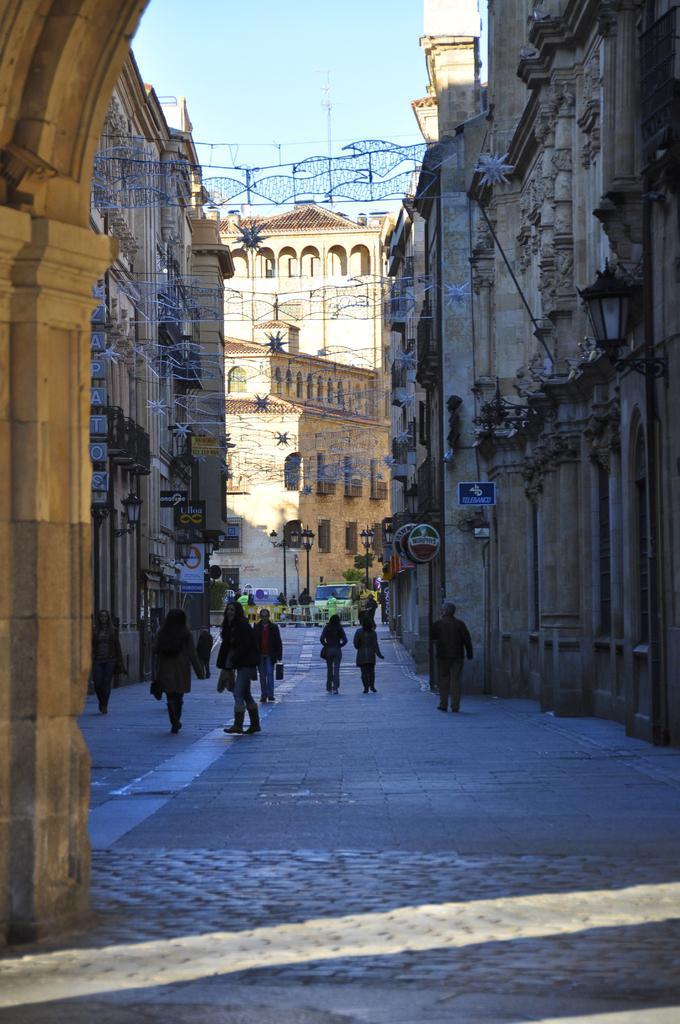Describe this image in one or two sentences. In this image I can see a path and number of people walking on it. I can also see number of buildings and decorations. In the background I can see clear blue sky. 